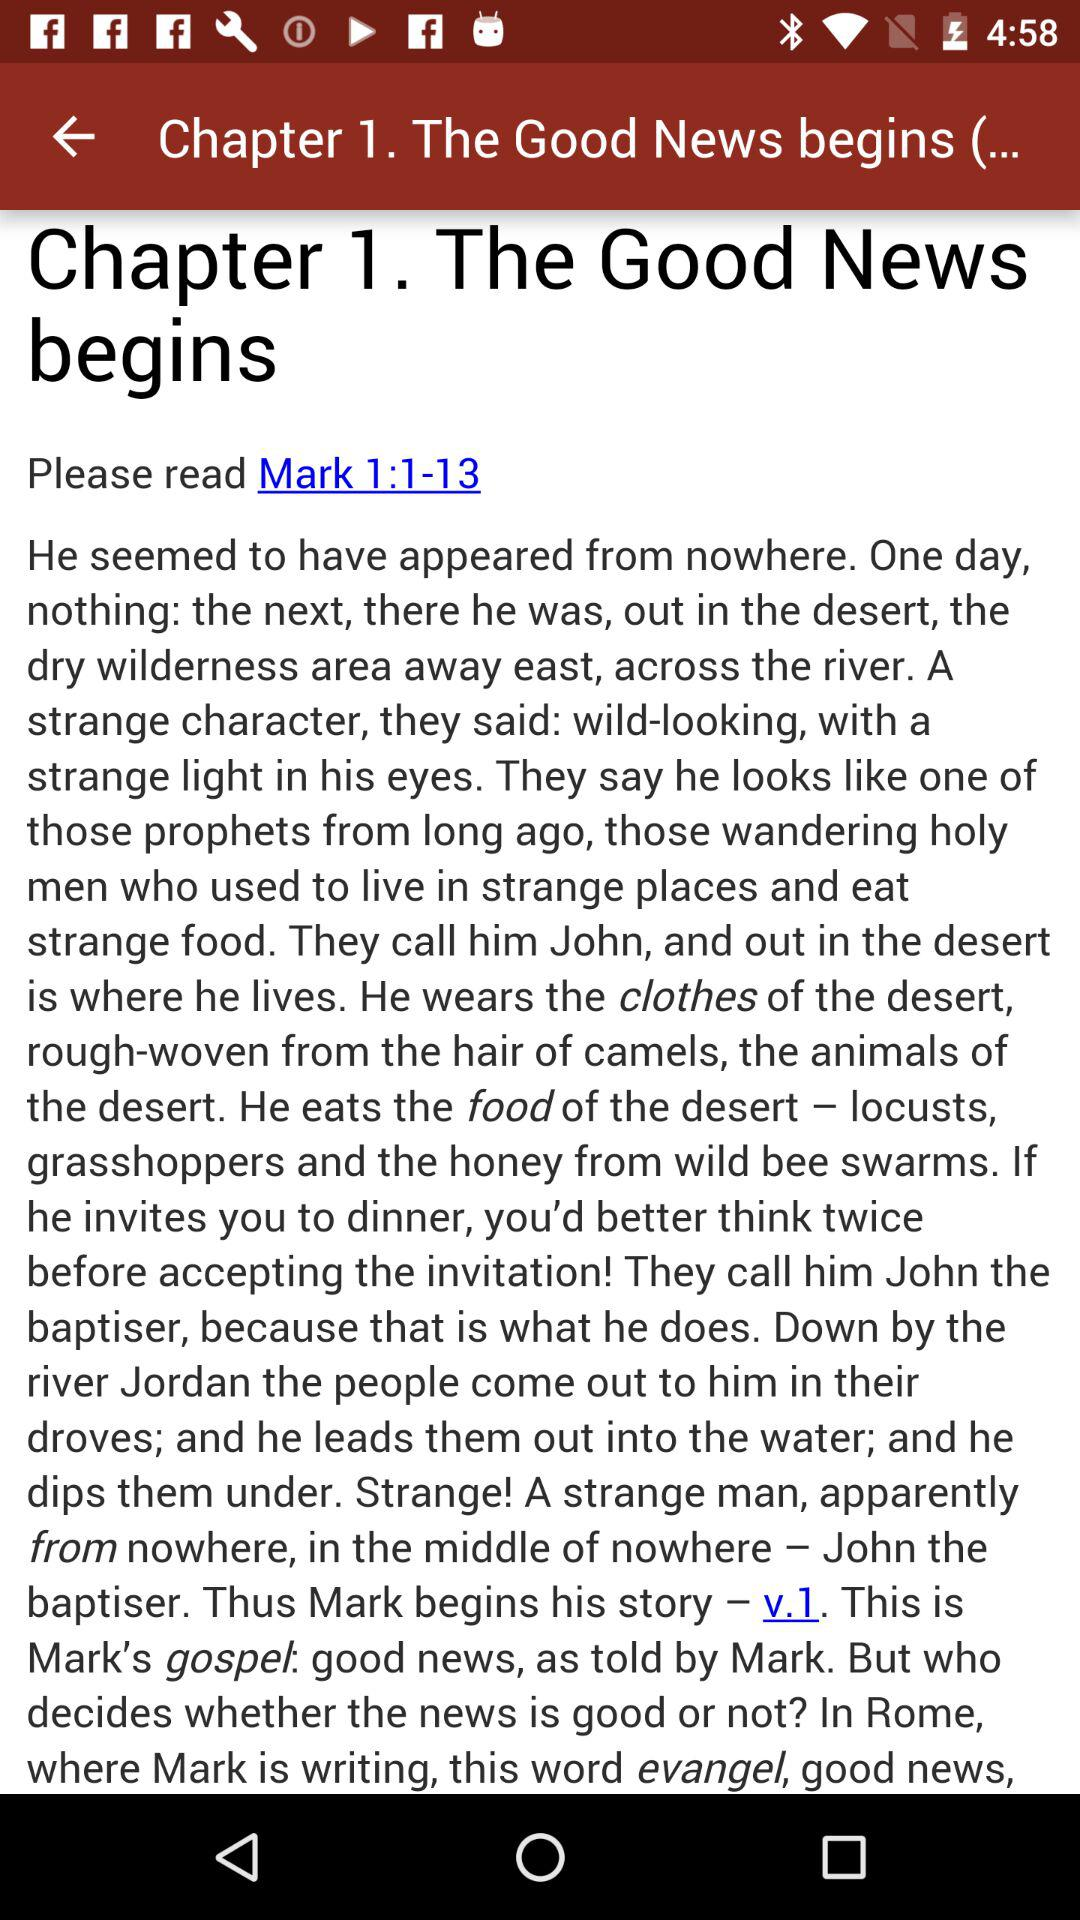What is the name of Chapter 1? The name of Chapter 1 is "The Good News begins". 